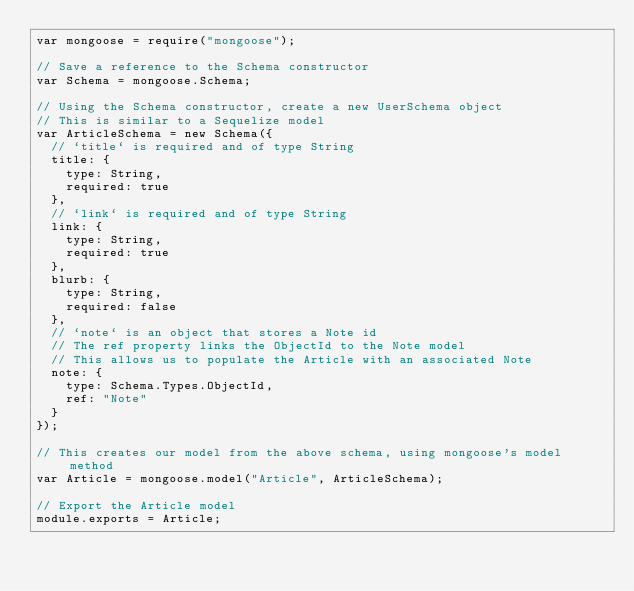Convert code to text. <code><loc_0><loc_0><loc_500><loc_500><_JavaScript_>var mongoose = require("mongoose");

// Save a reference to the Schema constructor
var Schema = mongoose.Schema;

// Using the Schema constructor, create a new UserSchema object
// This is similar to a Sequelize model
var ArticleSchema = new Schema({
  // `title` is required and of type String
  title: {
    type: String,
    required: true
  },
  // `link` is required and of type String
  link: {
    type: String,
    required: true
  },
  blurb: {
    type: String,
    required: false
  },
  // `note` is an object that stores a Note id
  // The ref property links the ObjectId to the Note model
  // This allows us to populate the Article with an associated Note
  note: {
    type: Schema.Types.ObjectId,
    ref: "Note"
  }
});

// This creates our model from the above schema, using mongoose's model method
var Article = mongoose.model("Article", ArticleSchema);

// Export the Article model
module.exports = Article;
</code> 